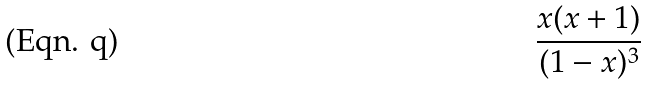Convert formula to latex. <formula><loc_0><loc_0><loc_500><loc_500>\frac { x ( x + 1 ) } { ( 1 - x ) ^ { 3 } }</formula> 